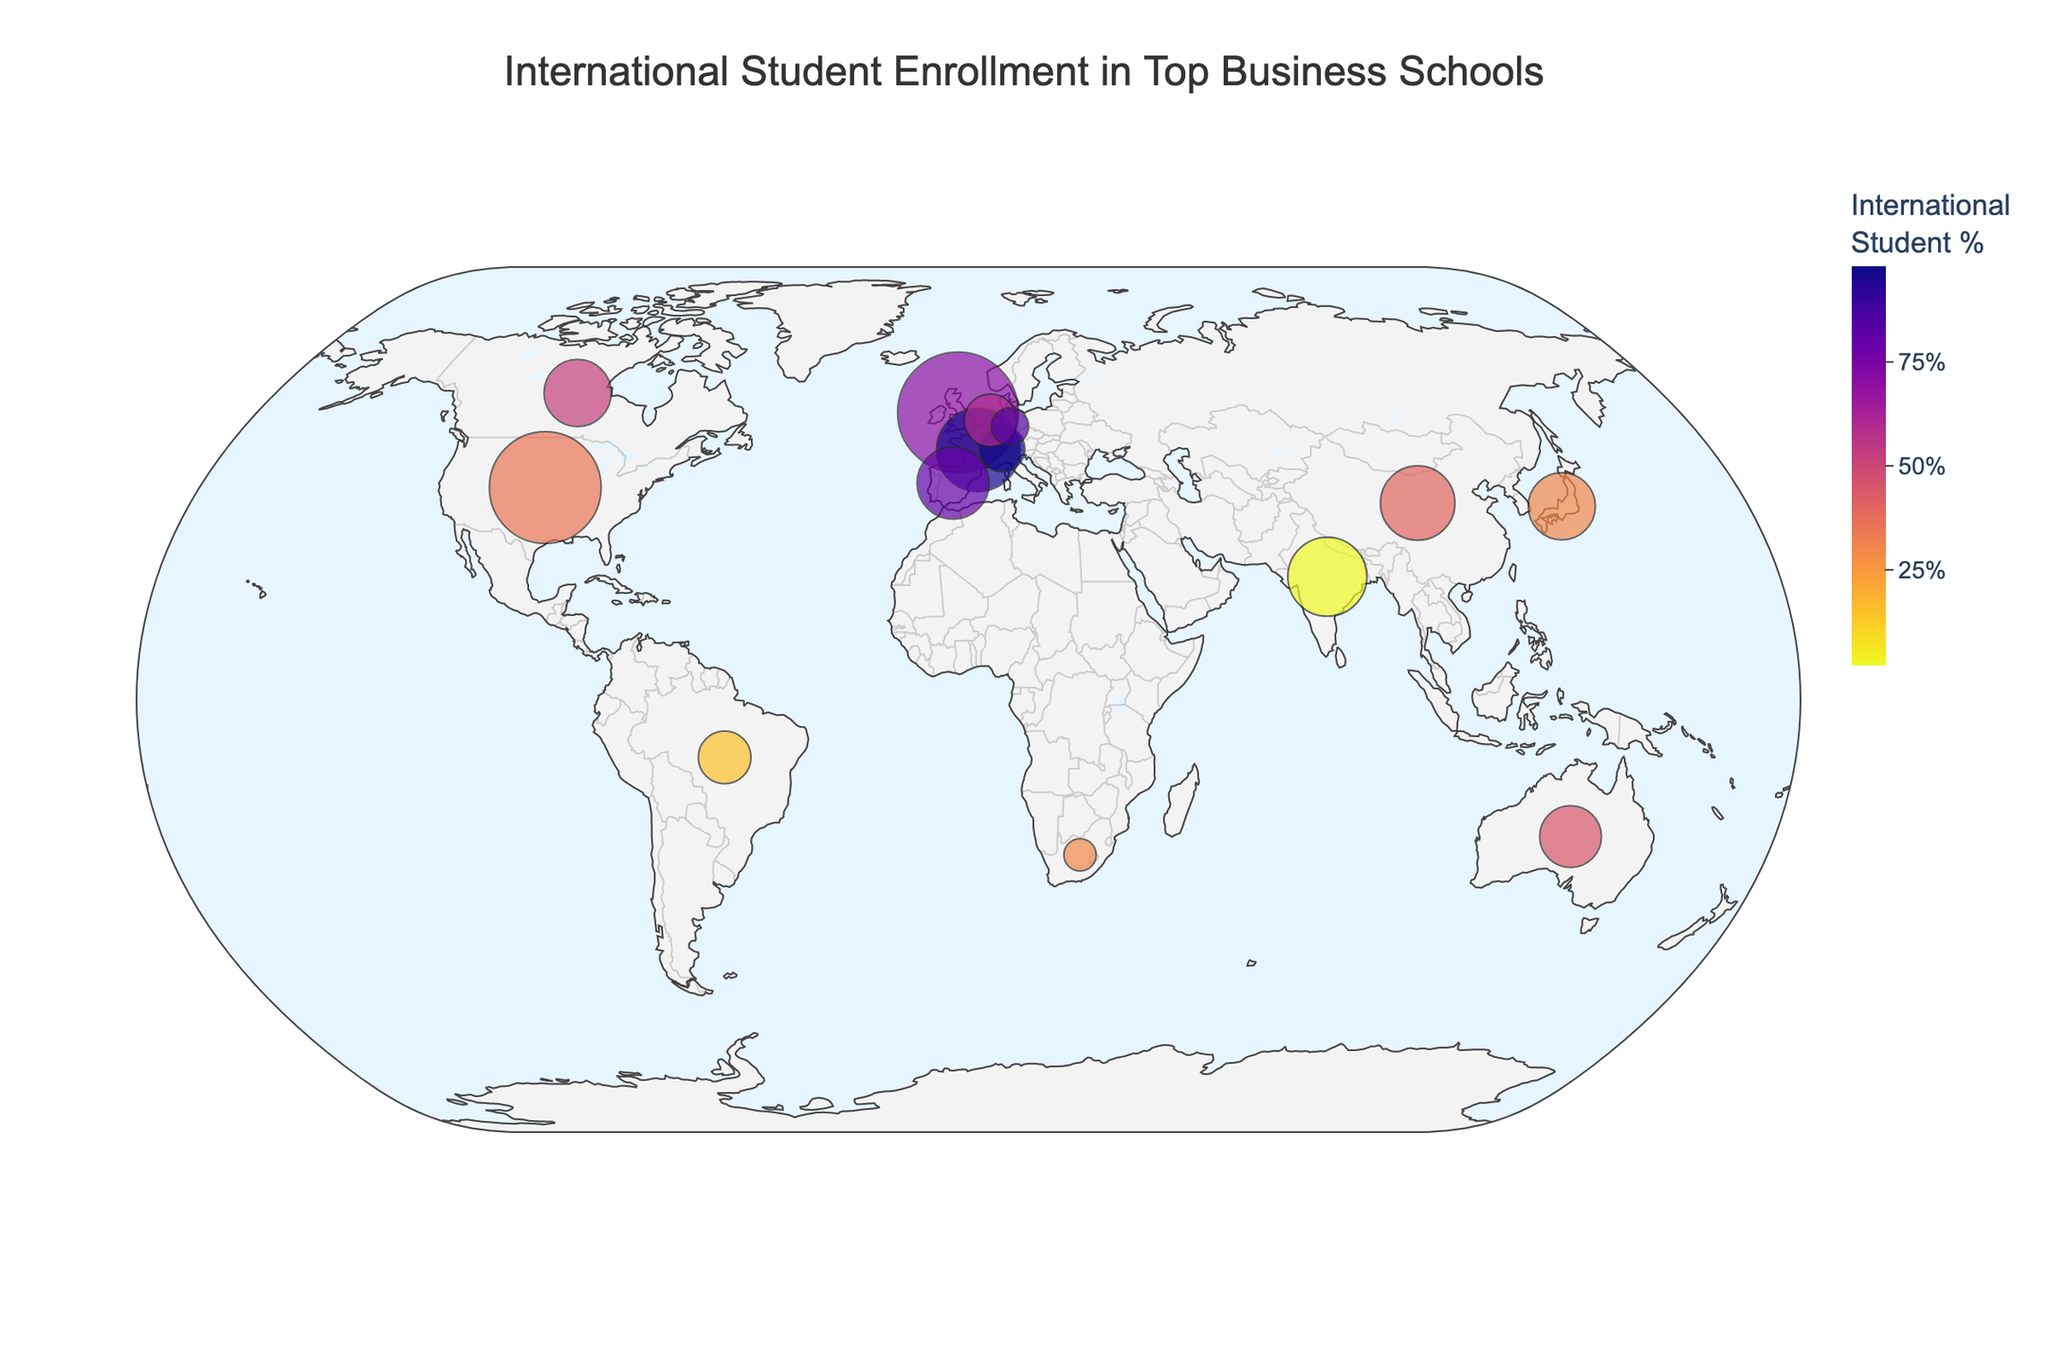what is the title of the figure? The title is usually placed at the top center of the figure. By reading the title directly, you can determine what the figure is about. In this case, the title is "International Student Enrollment in Top Business Schools".
Answer: International Student Enrollment in Top Business Schools Which business school has the highest international student percentage? Look at the color scale and the values for each business school. The highest percentage is represented by the darkest color on the color scale. INSEAD Asia Campus and IMD both have an international student percentage of 98%.
Answer: INSEAD Asia Campus and IMD What is the range of total enrollments shown in the figure? By examining the various bubble sizes, you can identify the smallest and largest enrollments. The smallest enrollment is at the University of Cape Town GSB (150) and the largest enrollment is at Harvard Business School (1800).
Answer: 150 to 1800 How many countries have business schools with over 75% international students? Look at the color scale and identify bubbles with colors that fall into the range of over 75%. There are four such countries: the UK (London Business School), France (INSEAD), Singapore (INSEAD Asia Campus), and Switzerland (IMD).
Answer: 4 Which region has the densest concentration of highly international business schools? Observe the geographic distribution of bubbles with high international student percentages. Europe has a high concentration with schools like London Business School, INSEAD, and IMD.
Answer: Europe Compare the international student percentages between Harvard Business School and CEIBS. Which one has a higher percentage and by how much? Locate the bubbles for Harvard Business School and CEIBS. Harvard's percentage is 35%, and CEIBS is 40%. The difference is 40% - 35% = 5%.
Answer: CEIBS by 5% What is the total student enrollment for business schools in countries with less than 10% international students? Identify the countries and their business schools with less than 10%: only the Indian School of Business (2%). The total enrollment for this school is 900.
Answer: 900 Which business school has the smallest total enrollment, and what percentage of its students are international? Find the smallest bubble which corresponds to the smallest size. ESMT Berlin has the smallest enrollment of 200 students and the international percentage is 85%.
Answer: ESMT Berlin, 85% How does the international student percentage at GLOBIS University compare to that at the University of Cape Town GSB? Locate the bubbles for GLOBIS University and the University of Cape Town GSB. GLOBIS has an international percentage of 30%, and the University of Cape Town GSB also has 30%.
Answer: They have the same percentage of 30% 